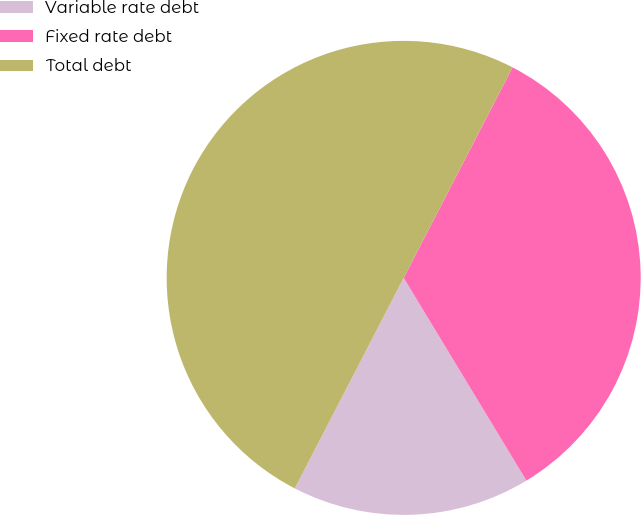<chart> <loc_0><loc_0><loc_500><loc_500><pie_chart><fcel>Variable rate debt<fcel>Fixed rate debt<fcel>Total debt<nl><fcel>16.26%<fcel>33.74%<fcel>50.0%<nl></chart> 